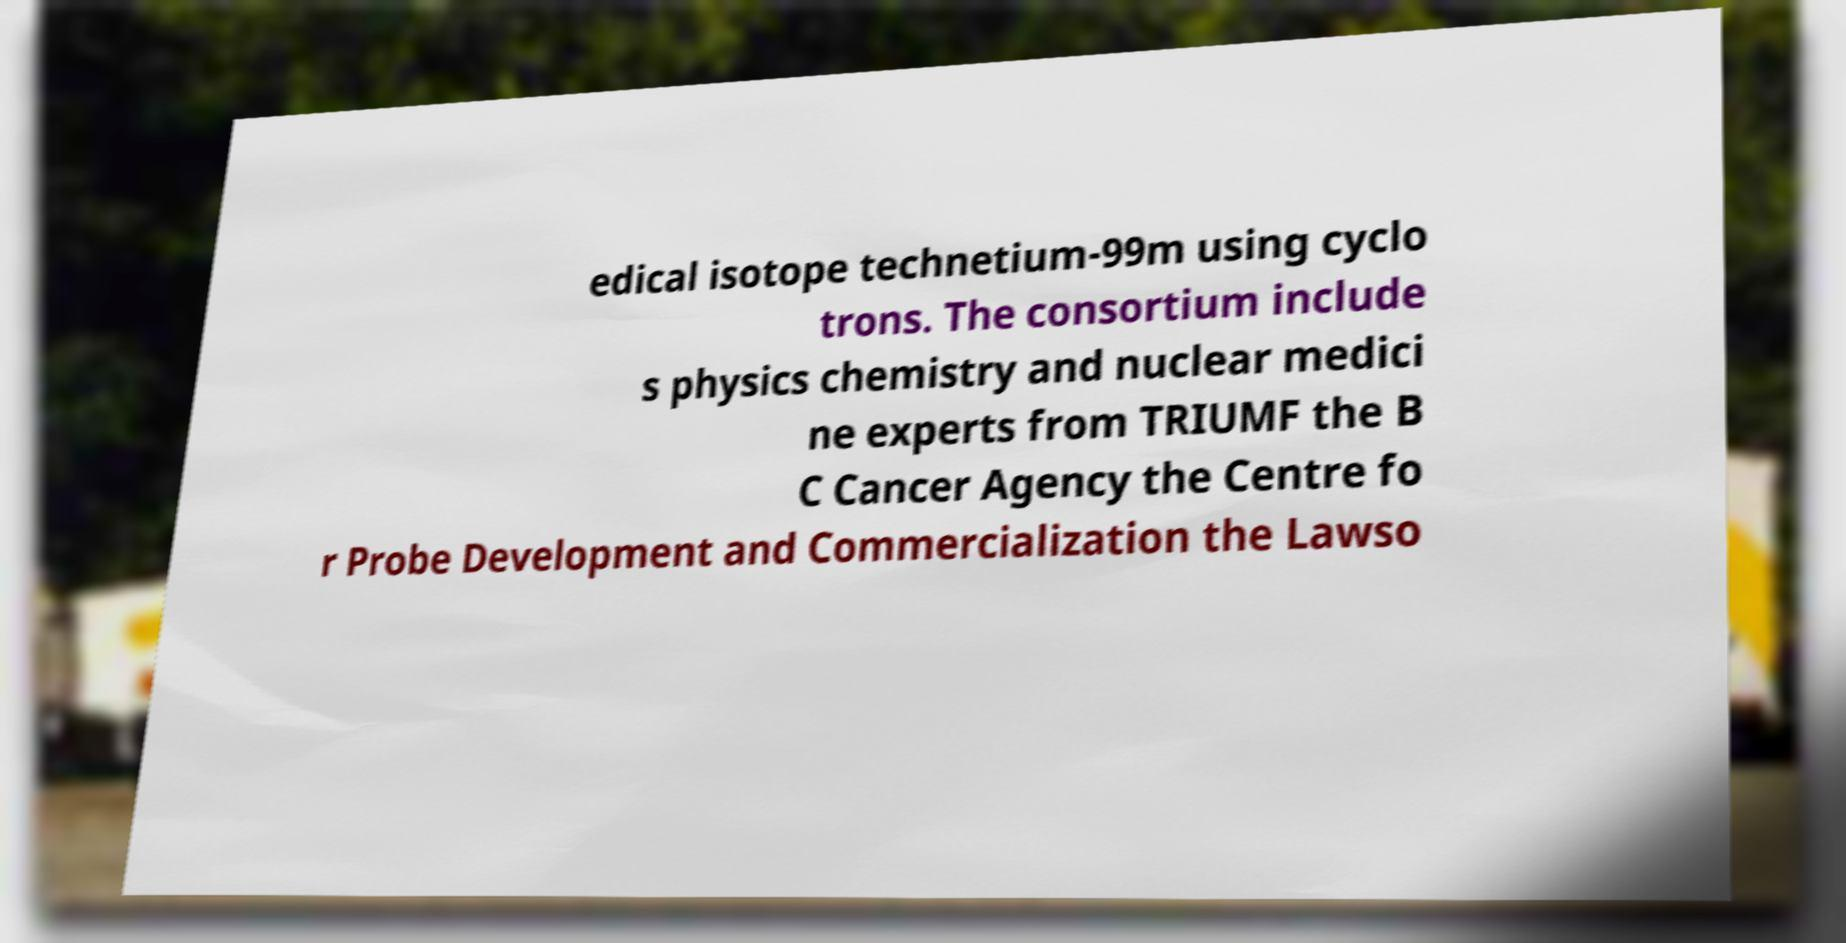Please read and relay the text visible in this image. What does it say? edical isotope technetium-99m using cyclo trons. The consortium include s physics chemistry and nuclear medici ne experts from TRIUMF the B C Cancer Agency the Centre fo r Probe Development and Commercialization the Lawso 